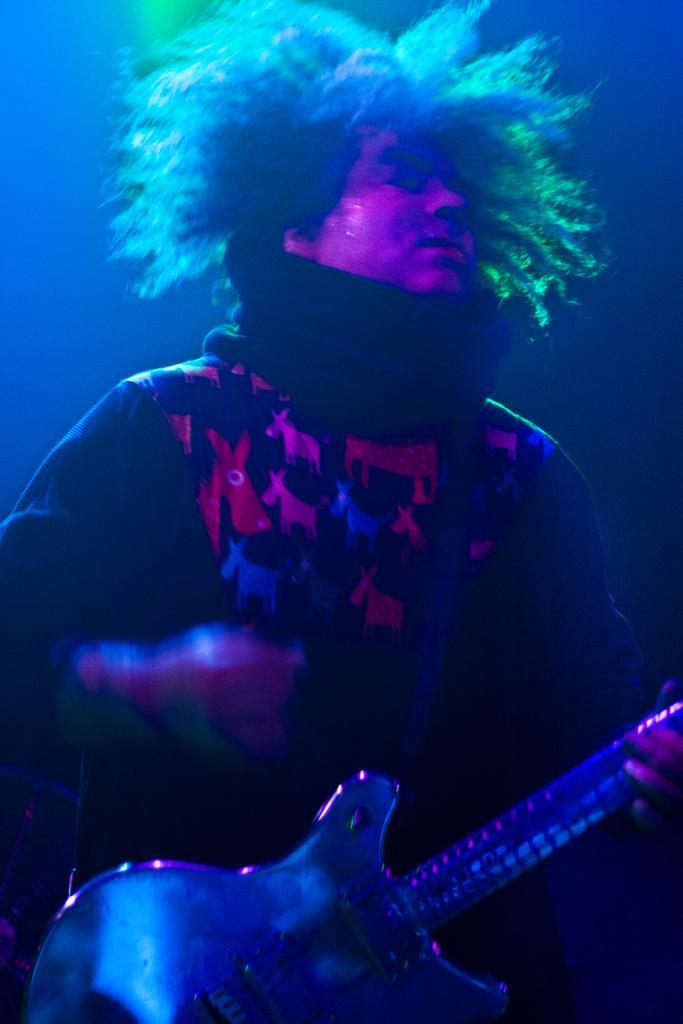How would you summarize this image in a sentence or two? Here I can see a person standing and playing the guitar by looking at the right side. The background is dark. 